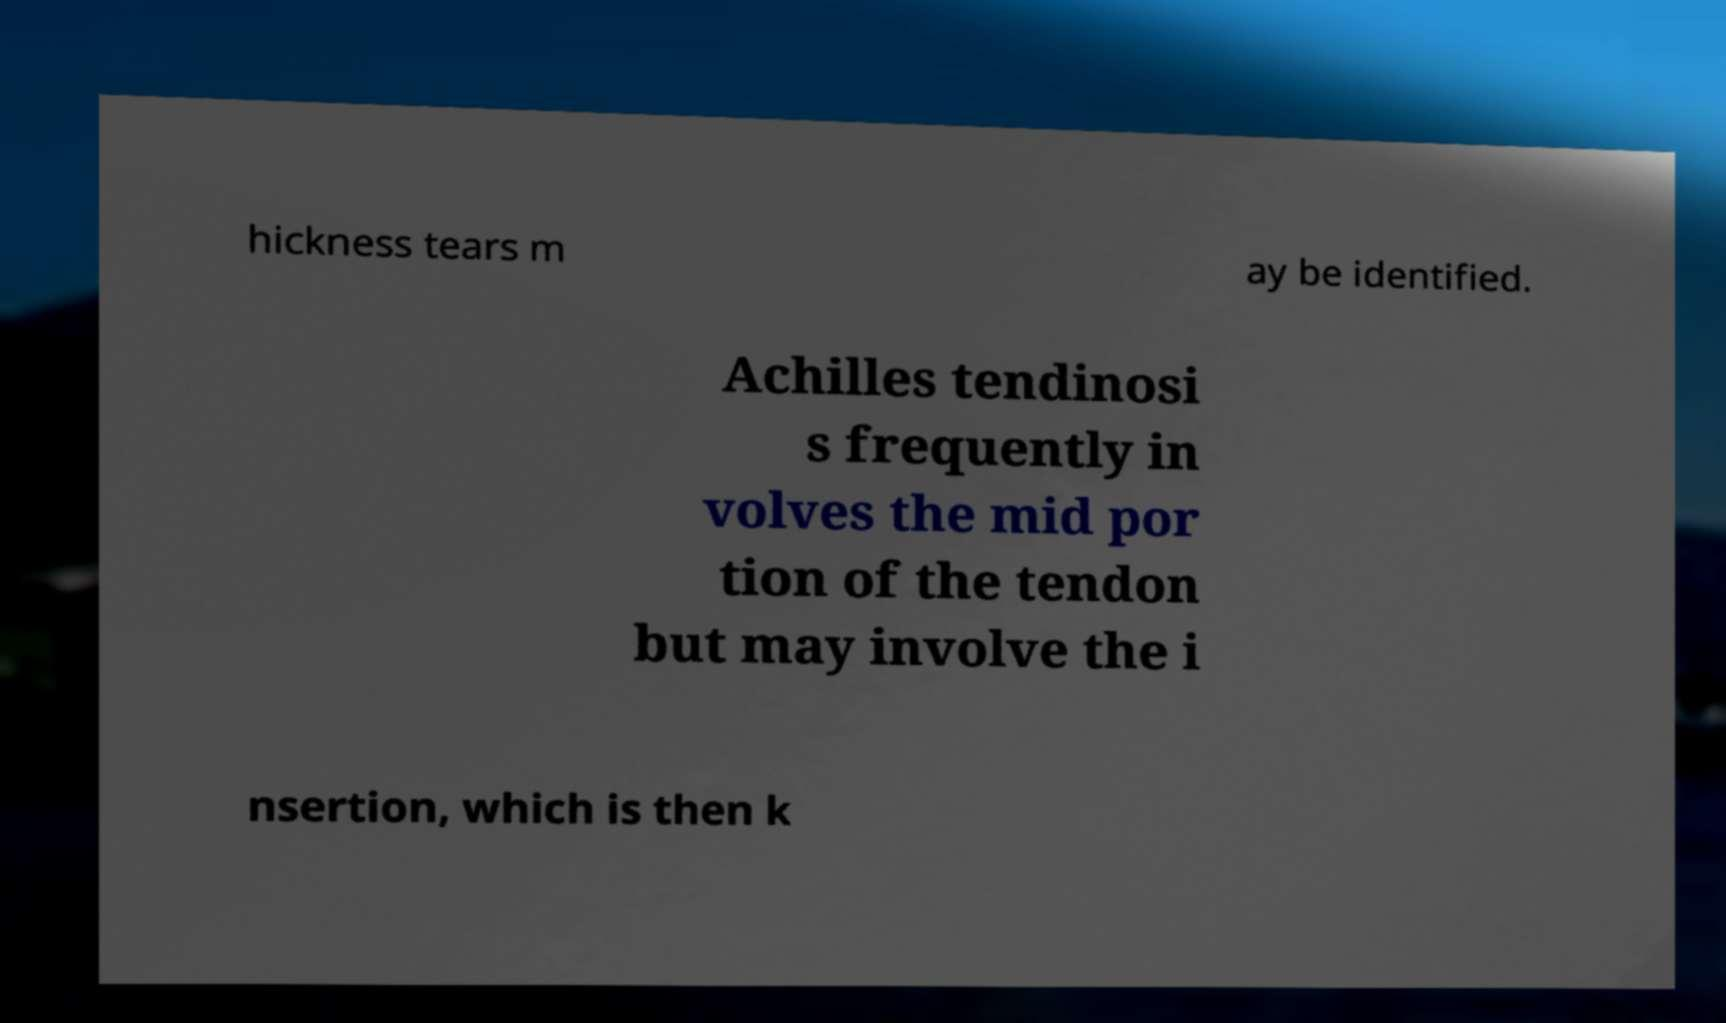Can you read and provide the text displayed in the image?This photo seems to have some interesting text. Can you extract and type it out for me? hickness tears m ay be identified. Achilles tendinosi s frequently in volves the mid por tion of the tendon but may involve the i nsertion, which is then k 